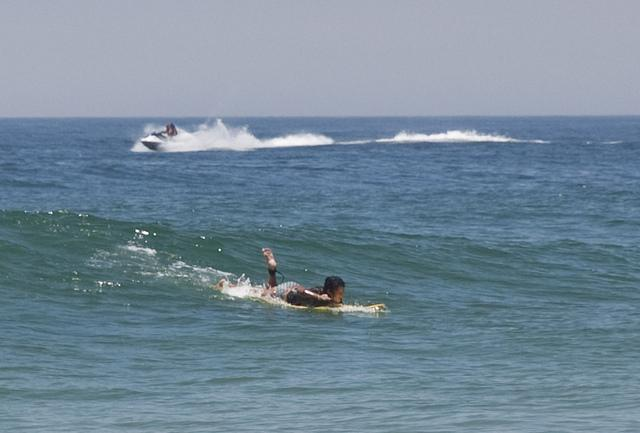Which person seen here goes faster over time? jet ski 